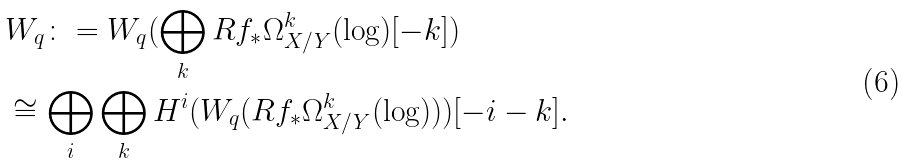Convert formula to latex. <formula><loc_0><loc_0><loc_500><loc_500>& W _ { q } \colon = W _ { q } ( \bigoplus _ { k } R f _ { * } \Omega ^ { k } _ { X / Y } ( \log ) [ - k ] ) \\ & \cong \bigoplus _ { i } \bigoplus _ { k } H ^ { i } ( W _ { q } ( R f _ { * } \Omega ^ { k } _ { X / Y } ( \log ) ) ) [ - i - k ] .</formula> 